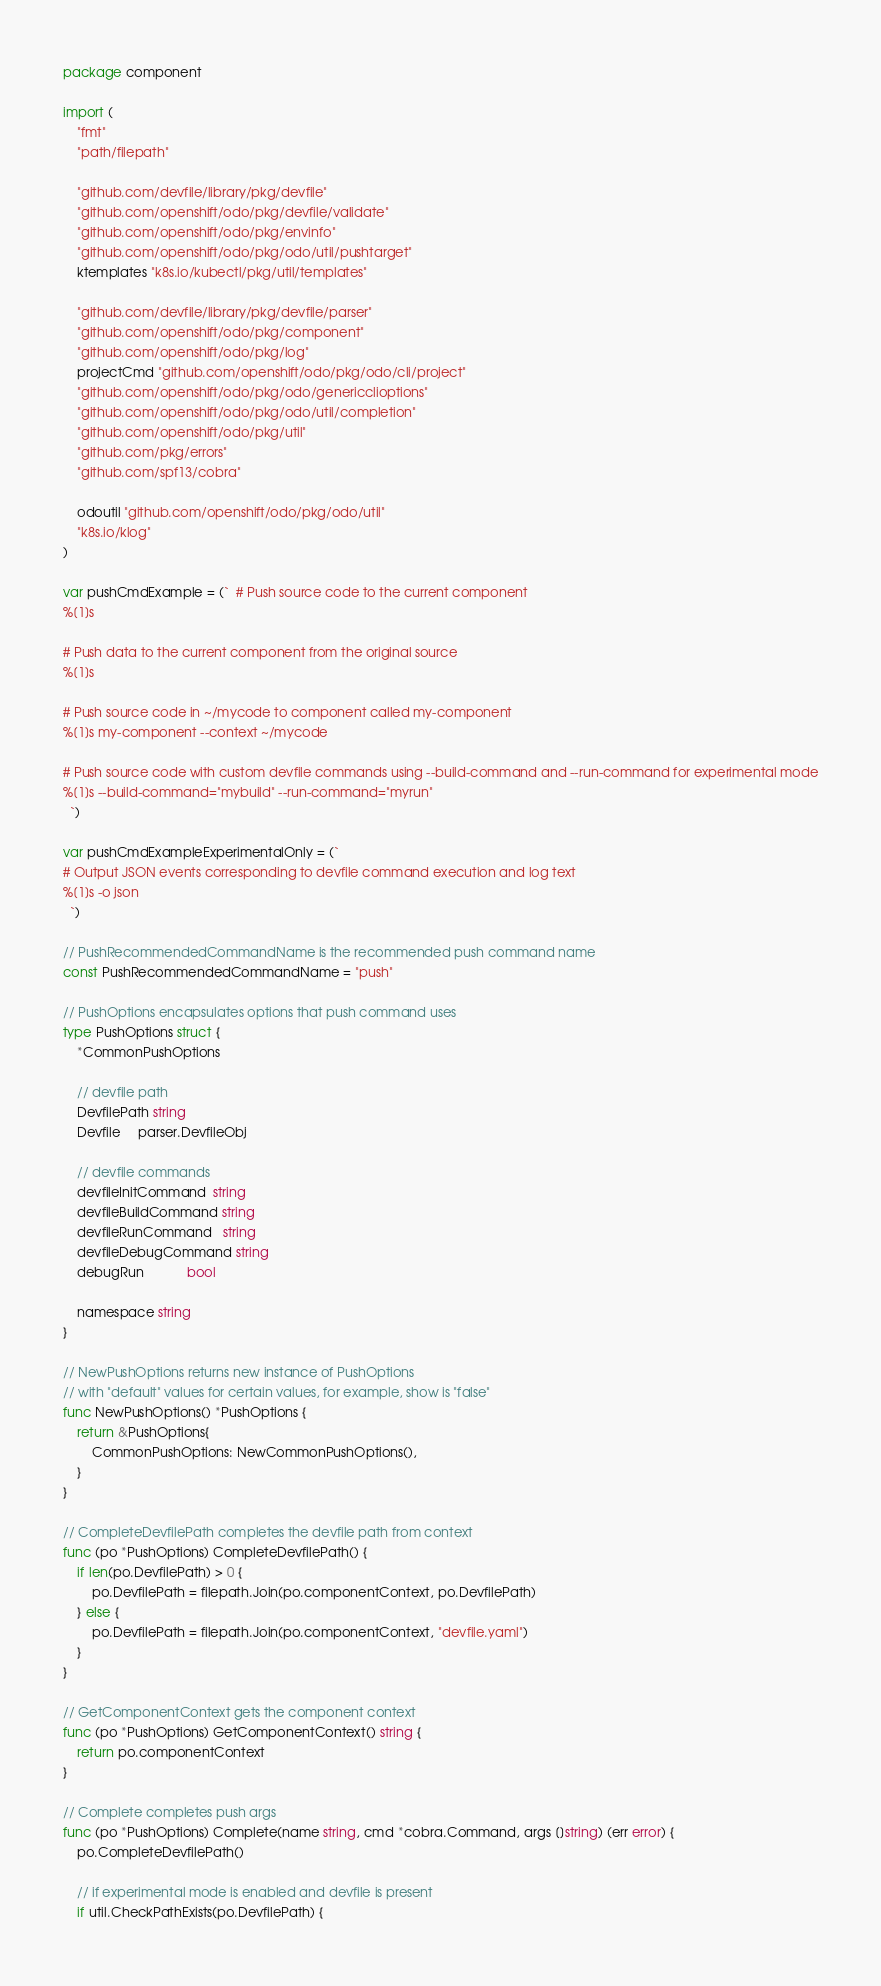Convert code to text. <code><loc_0><loc_0><loc_500><loc_500><_Go_>package component

import (
	"fmt"
	"path/filepath"

	"github.com/devfile/library/pkg/devfile"
	"github.com/openshift/odo/pkg/devfile/validate"
	"github.com/openshift/odo/pkg/envinfo"
	"github.com/openshift/odo/pkg/odo/util/pushtarget"
	ktemplates "k8s.io/kubectl/pkg/util/templates"

	"github.com/devfile/library/pkg/devfile/parser"
	"github.com/openshift/odo/pkg/component"
	"github.com/openshift/odo/pkg/log"
	projectCmd "github.com/openshift/odo/pkg/odo/cli/project"
	"github.com/openshift/odo/pkg/odo/genericclioptions"
	"github.com/openshift/odo/pkg/odo/util/completion"
	"github.com/openshift/odo/pkg/util"
	"github.com/pkg/errors"
	"github.com/spf13/cobra"

	odoutil "github.com/openshift/odo/pkg/odo/util"
	"k8s.io/klog"
)

var pushCmdExample = (`  # Push source code to the current component
%[1]s

# Push data to the current component from the original source
%[1]s

# Push source code in ~/mycode to component called my-component
%[1]s my-component --context ~/mycode

# Push source code with custom devfile commands using --build-command and --run-command for experimental mode
%[1]s --build-command="mybuild" --run-command="myrun"
  `)

var pushCmdExampleExperimentalOnly = (`
# Output JSON events corresponding to devfile command execution and log text
%[1]s -o json
  `)

// PushRecommendedCommandName is the recommended push command name
const PushRecommendedCommandName = "push"

// PushOptions encapsulates options that push command uses
type PushOptions struct {
	*CommonPushOptions

	// devfile path
	DevfilePath string
	Devfile     parser.DevfileObj

	// devfile commands
	devfileInitCommand  string
	devfileBuildCommand string
	devfileRunCommand   string
	devfileDebugCommand string
	debugRun            bool

	namespace string
}

// NewPushOptions returns new instance of PushOptions
// with "default" values for certain values, for example, show is "false"
func NewPushOptions() *PushOptions {
	return &PushOptions{
		CommonPushOptions: NewCommonPushOptions(),
	}
}

// CompleteDevfilePath completes the devfile path from context
func (po *PushOptions) CompleteDevfilePath() {
	if len(po.DevfilePath) > 0 {
		po.DevfilePath = filepath.Join(po.componentContext, po.DevfilePath)
	} else {
		po.DevfilePath = filepath.Join(po.componentContext, "devfile.yaml")
	}
}

// GetComponentContext gets the component context
func (po *PushOptions) GetComponentContext() string {
	return po.componentContext
}

// Complete completes push args
func (po *PushOptions) Complete(name string, cmd *cobra.Command, args []string) (err error) {
	po.CompleteDevfilePath()

	// if experimental mode is enabled and devfile is present
	if util.CheckPathExists(po.DevfilePath) {
</code> 